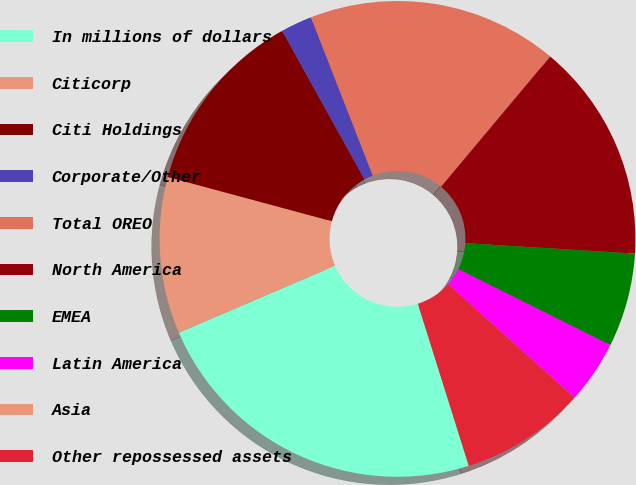Convert chart to OTSL. <chart><loc_0><loc_0><loc_500><loc_500><pie_chart><fcel>In millions of dollars<fcel>Citicorp<fcel>Citi Holdings<fcel>Corporate/Other<fcel>Total OREO<fcel>North America<fcel>EMEA<fcel>Latin America<fcel>Asia<fcel>Other repossessed assets<nl><fcel>23.4%<fcel>10.64%<fcel>12.76%<fcel>2.13%<fcel>17.02%<fcel>14.89%<fcel>6.39%<fcel>4.26%<fcel>0.01%<fcel>8.51%<nl></chart> 